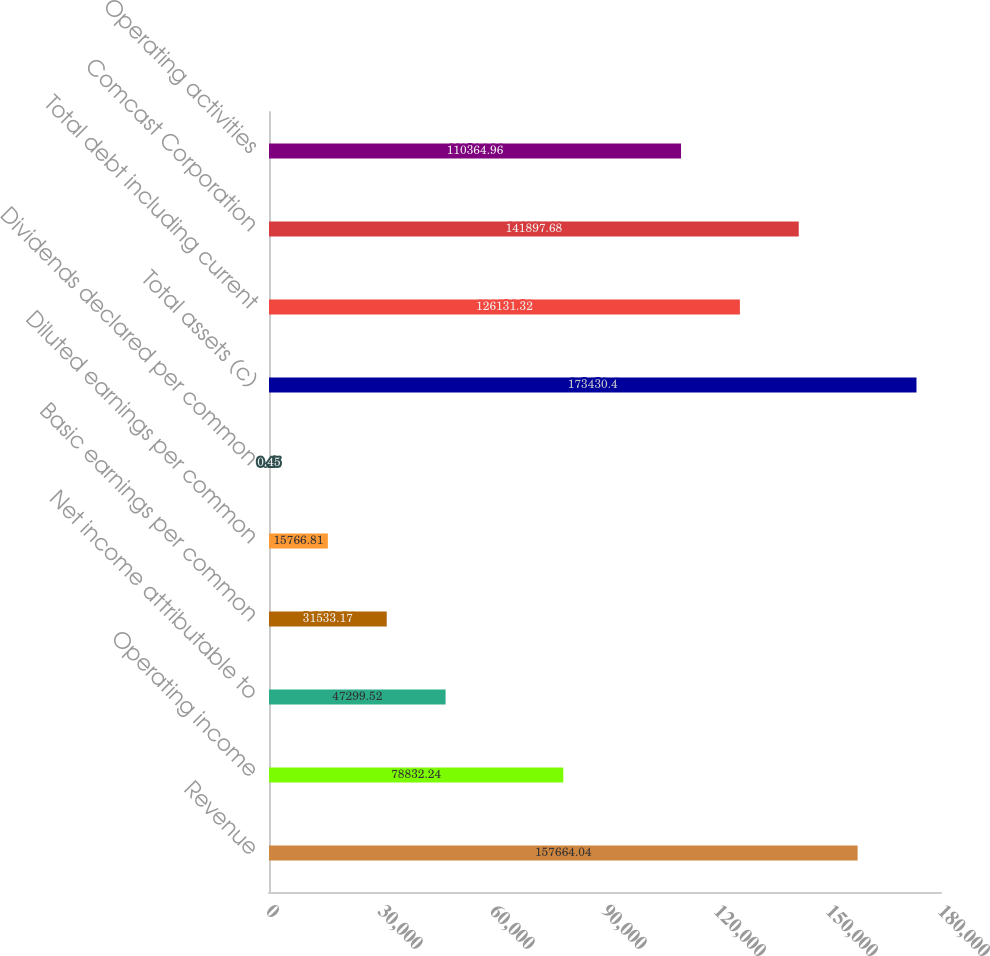Convert chart. <chart><loc_0><loc_0><loc_500><loc_500><bar_chart><fcel>Revenue<fcel>Operating income<fcel>Net income attributable to<fcel>Basic earnings per common<fcel>Diluted earnings per common<fcel>Dividends declared per common<fcel>Total assets (c)<fcel>Total debt including current<fcel>Comcast Corporation<fcel>Operating activities<nl><fcel>157664<fcel>78832.2<fcel>47299.5<fcel>31533.2<fcel>15766.8<fcel>0.45<fcel>173430<fcel>126131<fcel>141898<fcel>110365<nl></chart> 